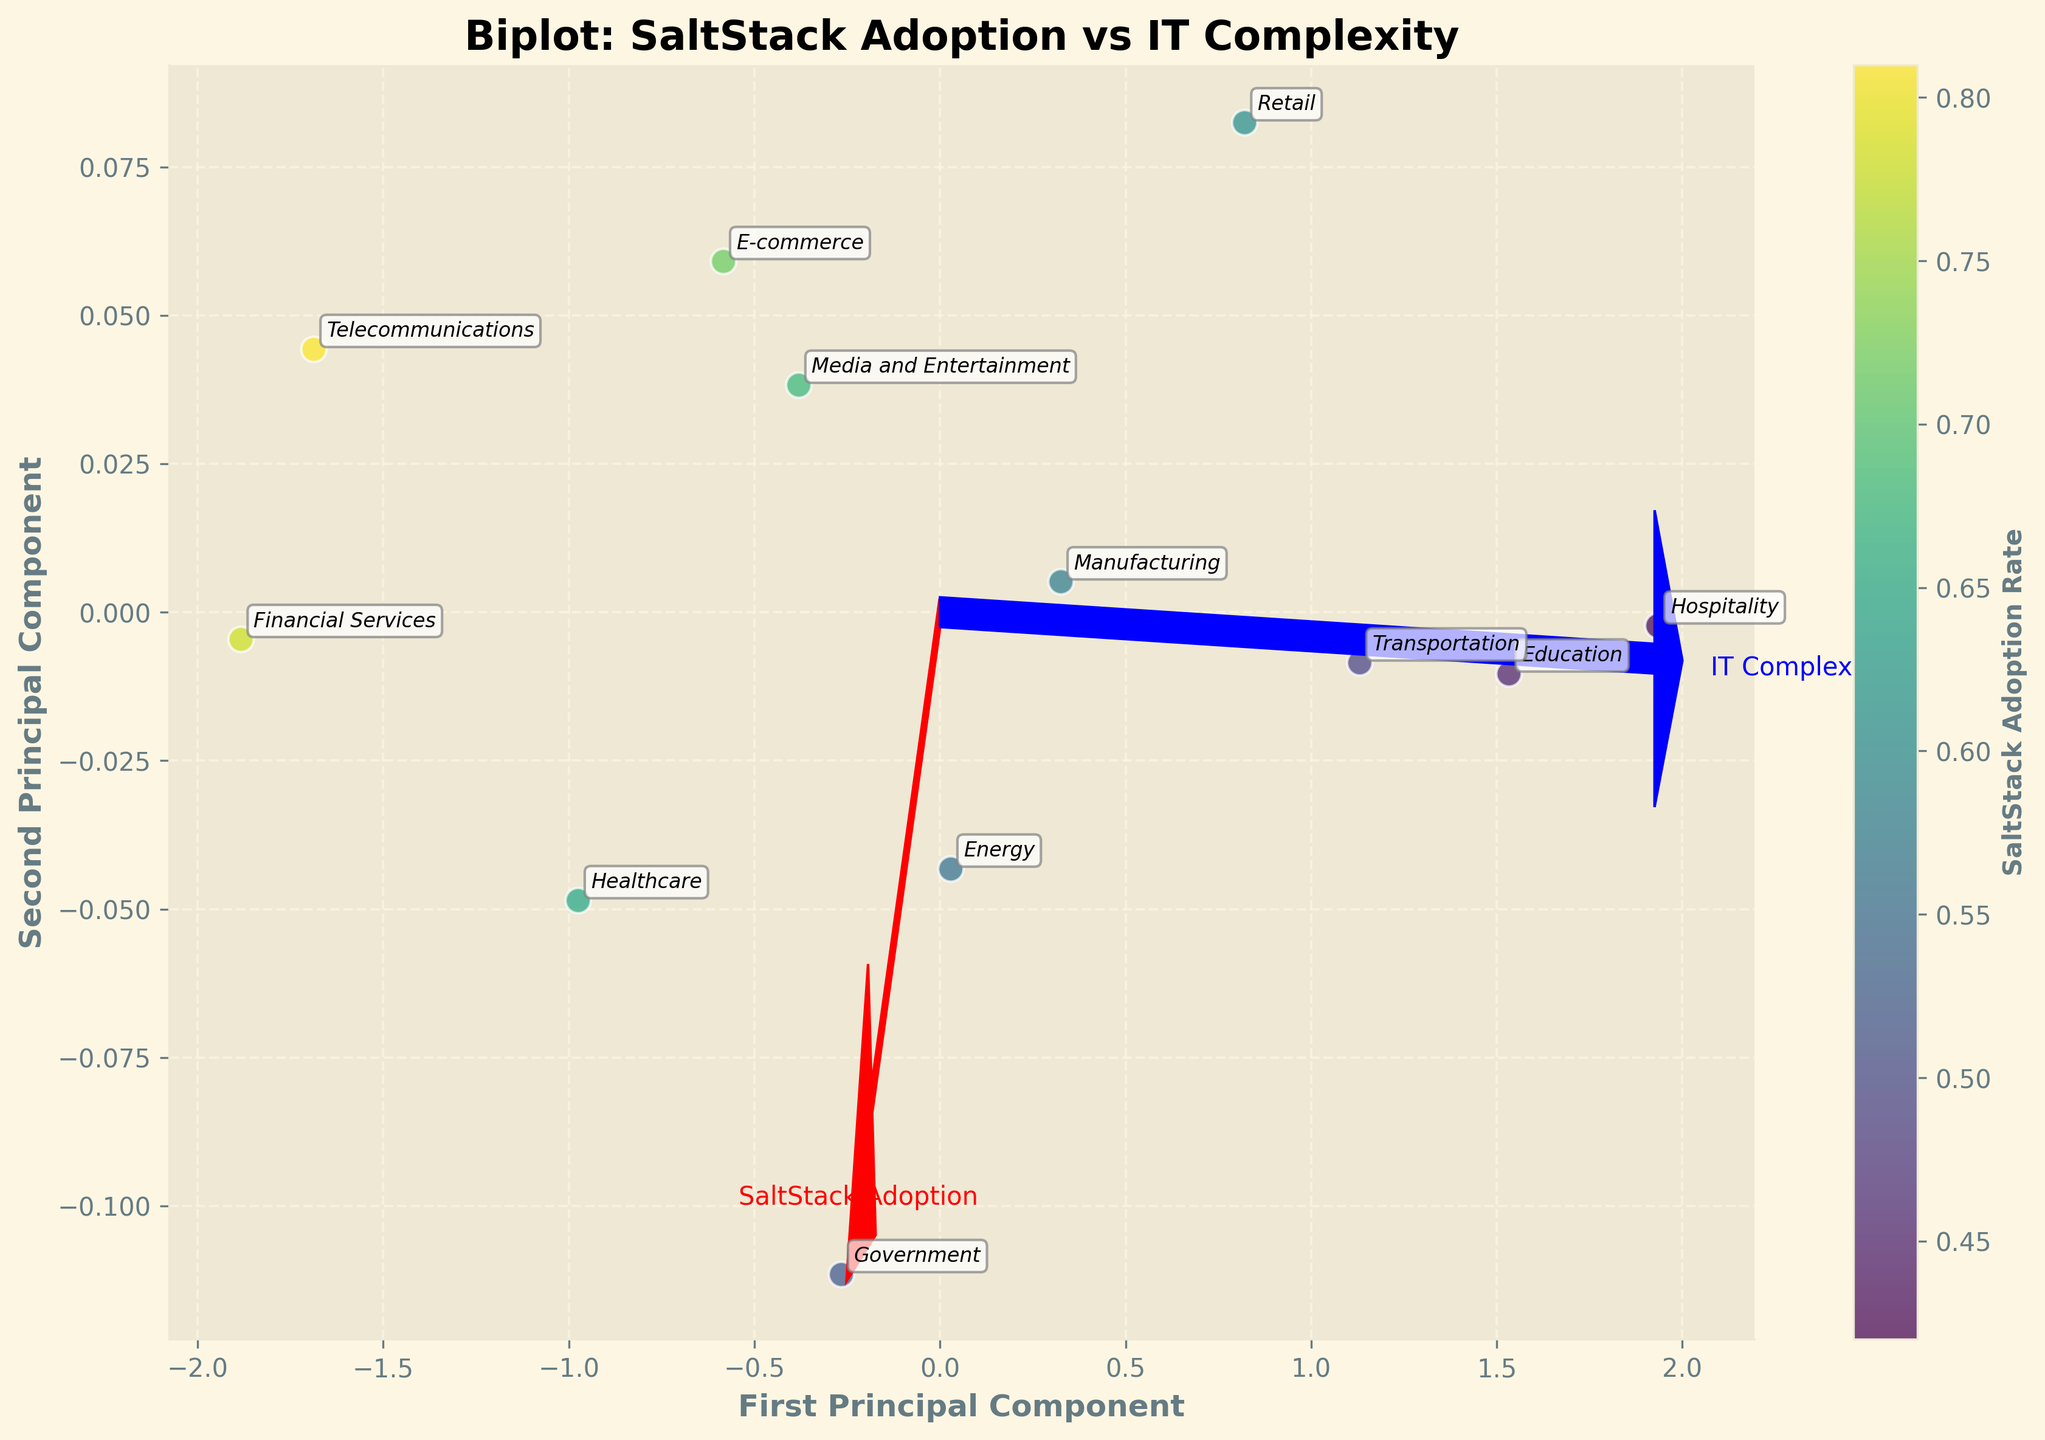What is the relationship between the first principal component and SaltStack adoption? The first principal component on the x-axis shows the relative positions of the industries after PCA transformation. By analyzing the color gradient, which represents the SaltStack adoption rate, industries with higher SaltStack adoption rates tend to have higher values on the first principal component.
Answer: Positive correlation What industry has the highest SaltStack adoption rate? The color scale on the scatter points indicates that 'Telecommunications' has the darkest color among the industries, representing the highest SaltStack adoption rate.
Answer: Telecommunications Which two industries are closest to each other on the biplot? By examining the proximity of the scatter points, 'Healthcare' and 'Media and Entertainment' are closest to each other, situated very near on the plot.
Answer: Healthcare and Media and Entertainment How does IT Infrastructure Complexity influence the second principal component? The arrows representing 'IT Complexity' and the second principal component suggest a positive correlation. Industries with higher IT complexity tend to align higher on the second principal component.
Answer: Positive correlation Compare the IT infrastructure complexity of the Financial Services industry to the Energy industry. By looking at the positions and vectors, Financial Services is higher on the IT Complexity axis compared to Energy, suggesting it has greater IT infrastructure complexity.
Answer: Financial Services has greater complexity Which industry has a relatively low SaltStack adoption rate but high IT infrastructure complexity? The 'Government' industry, placed on the upper-left section of the biplot, shows a moderate color gradient (lower adoption rate) and is positioned higher on the IT Complexity vector.
Answer: Government What features are represented by the blue and red arrows in the plot? The red arrow represents 'SaltStack Adoption', while the blue arrow represents 'IT Complexity,' indicated by their positions and extending directions.
Answer: SaltStack Adoption and IT Complexity Identify an industry with low IT infrastructure complexity and low SaltStack adoption rate. The 'Hospitality' industry is located lower on the IT Complexity axis and has a lighter color, indicating low SaltStack adoption.
Answer: Hospitality Looking at the vector directions of the features, which feature is more influential on the first principal component? The red arrow (SaltStack Adoption) aligns more closely with the direction of the first principal component, indicating it has a stronger influence.
Answer: SaltStack Adoption 